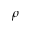<formula> <loc_0><loc_0><loc_500><loc_500>\rho</formula> 